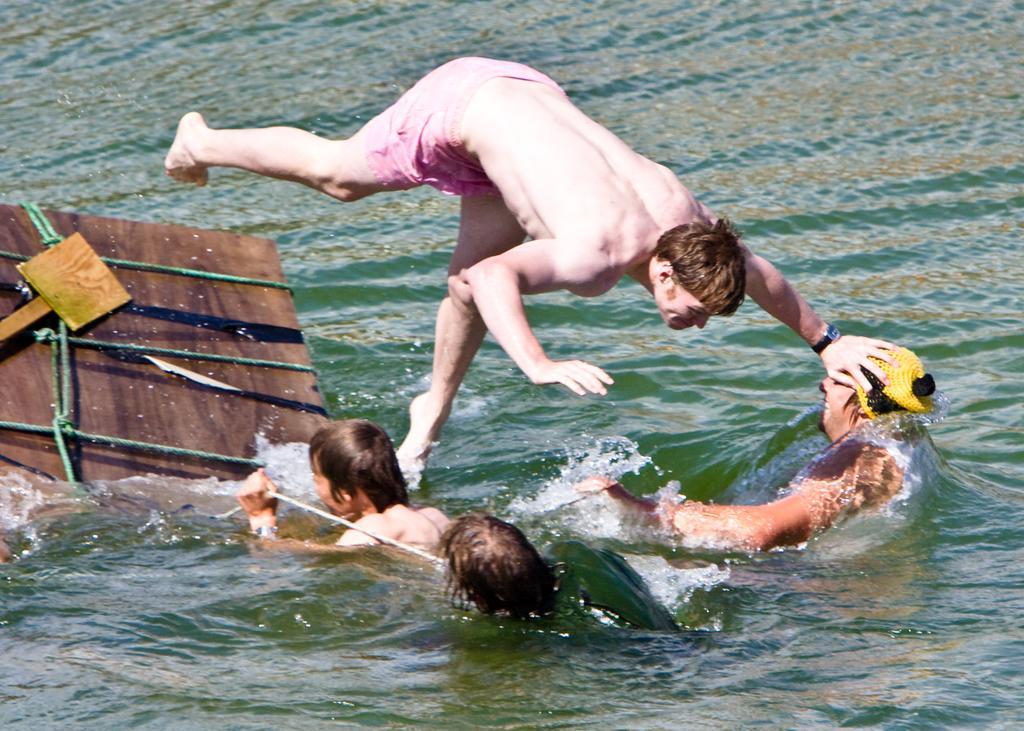Describe this image in one or two sentences. In this picture we can see few people in the water and a man is jumping into the water, on the left side of the image we can see an object and it is tied with ropes. 